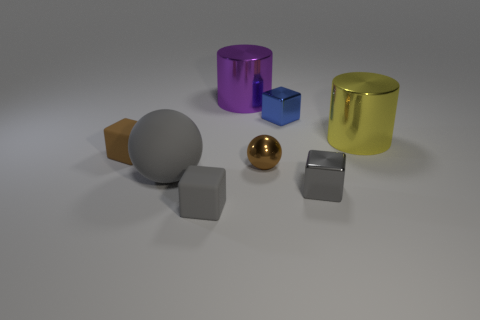There is a big object that is right of the big gray sphere and to the left of the tiny blue shiny thing; what is its shape? cylinder 